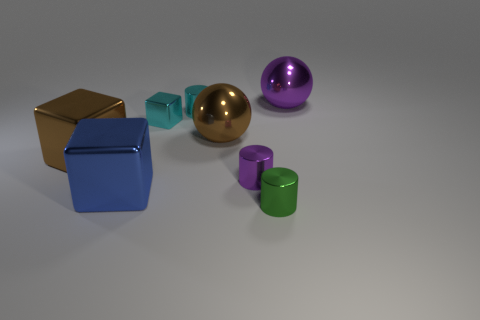Add 1 tiny blue objects. How many objects exist? 9 Subtract all balls. How many objects are left? 6 Add 6 gray metallic cylinders. How many gray metallic cylinders exist? 6 Subtract 0 green balls. How many objects are left? 8 Subtract all small balls. Subtract all tiny cyan blocks. How many objects are left? 7 Add 3 cyan shiny blocks. How many cyan shiny blocks are left? 4 